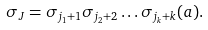Convert formula to latex. <formula><loc_0><loc_0><loc_500><loc_500>\sigma _ { J } = \sigma _ { j _ { 1 } + 1 } \sigma _ { j _ { 2 } + 2 } \dots \sigma _ { j _ { k } + k } ( a ) .</formula> 